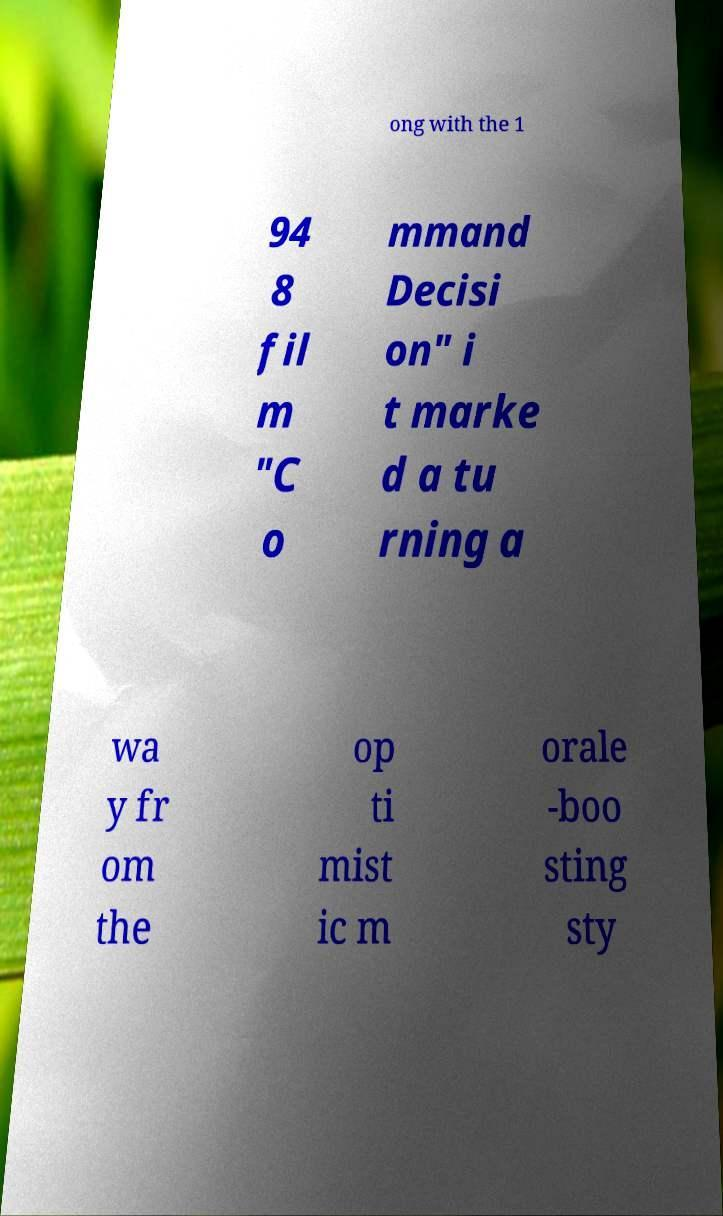Can you accurately transcribe the text from the provided image for me? ong with the 1 94 8 fil m "C o mmand Decisi on" i t marke d a tu rning a wa y fr om the op ti mist ic m orale -boo sting sty 